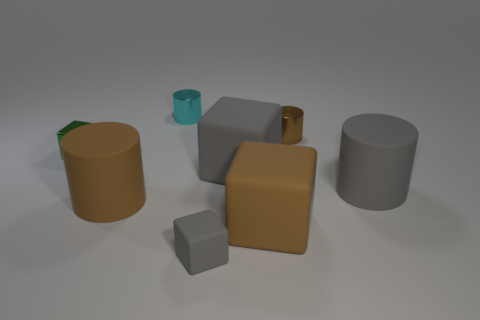There is a small matte block; is its color the same as the big cylinder that is right of the cyan cylinder?
Give a very brief answer. Yes. How many large blocks have the same color as the tiny rubber object?
Your response must be concise. 1. Do the large cylinder that is right of the small rubber block and the tiny matte object have the same color?
Provide a short and direct response. Yes. There is a small thing that is in front of the green cube; is its color the same as the large cylinder right of the large gray block?
Your answer should be very brief. Yes. There is a small cyan shiny object; are there any matte blocks behind it?
Give a very brief answer. No. How many other small green shiny things are the same shape as the green object?
Keep it short and to the point. 0. What is the color of the large rubber cylinder that is right of the brown matte thing right of the brown matte object that is behind the brown block?
Your response must be concise. Gray. Does the brown thing that is left of the tiny gray cube have the same material as the brown object behind the small green thing?
Provide a short and direct response. No. How many objects are either big gray objects to the left of the small brown metal object or red cylinders?
Ensure brevity in your answer.  1. How many objects are either gray cylinders or large brown matte blocks to the right of the cyan shiny object?
Your answer should be very brief. 2. 